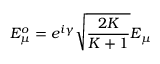Convert formula to latex. <formula><loc_0><loc_0><loc_500><loc_500>E _ { \mu } ^ { o } = e ^ { i \gamma } \sqrt { \frac { 2 K } { K + 1 } } E _ { \mu }</formula> 